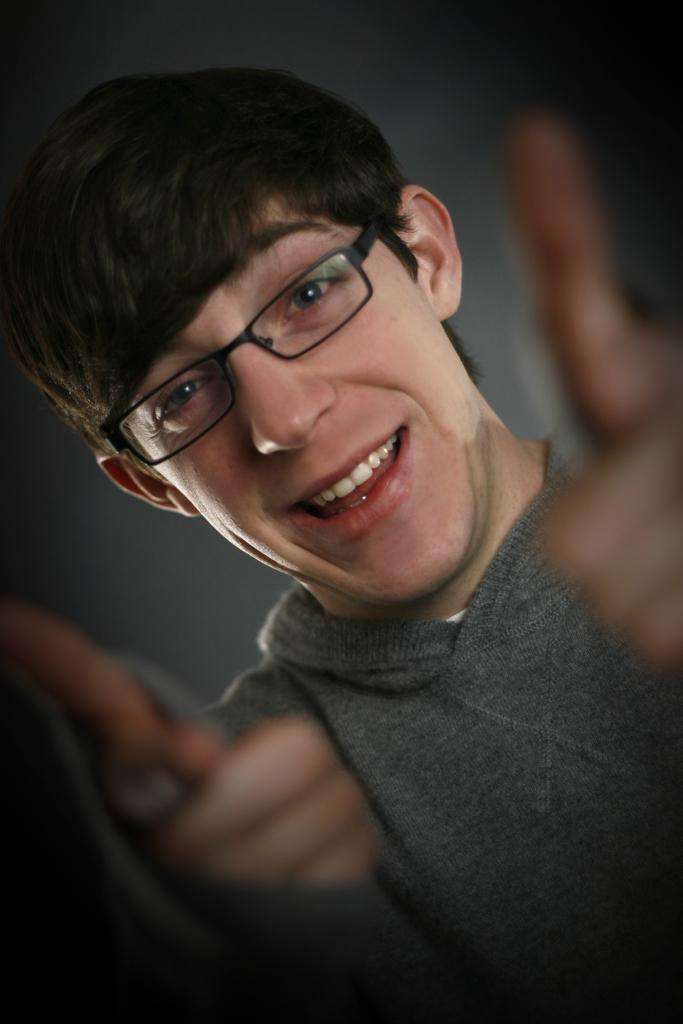Who is present in the image? There is a man in the image. What is the man wearing? The man is wearing a gray color shirt. What color can be seen in the background of the image? There is black color visible in the background of the image. What type of pickle is the man holding in the image? There is no pickle present in the image, and the man is not holding anything. 